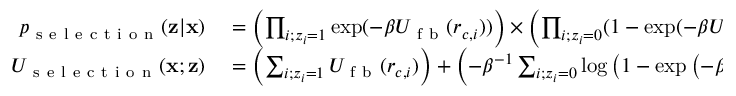Convert formula to latex. <formula><loc_0><loc_0><loc_500><loc_500>\begin{array} { r l } { p _ { s e l e c t i o n } ( z | x ) } & = \left ( \prod _ { i ; z _ { i } = 1 } \exp ( - \beta U _ { f b } ( r _ { c , i } ) ) \right ) \times \left ( \prod _ { i ; z _ { i } = 0 } ( 1 - \exp ( - \beta U _ { f b } ( r _ { c , i } ) ) ) \right ) } \\ { U _ { s e l e c t i o n } ( x ; z ) } & = \left ( \sum _ { i ; z _ { i } = 1 } U _ { f b } ( r _ { c , i } ) \right ) + \left ( - \beta ^ { - 1 } \sum _ { i ; z _ { i } = 0 } \log \left ( 1 - \exp \left ( - \beta U _ { f b } ( r _ { c , i } ) \right ) \right ) \right ) } \end{array}</formula> 